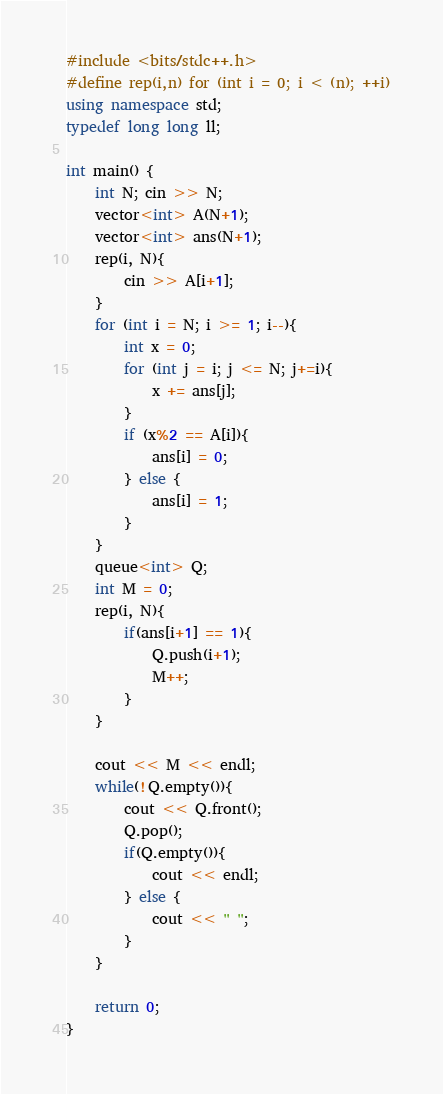Convert code to text. <code><loc_0><loc_0><loc_500><loc_500><_C++_>#include <bits/stdc++.h>
#define rep(i,n) for (int i = 0; i < (n); ++i)
using namespace std;
typedef long long ll;

int main() {
    int N; cin >> N;
    vector<int> A(N+1);
    vector<int> ans(N+1);
    rep(i, N){
        cin >> A[i+1];
    }
    for (int i = N; i >= 1; i--){
        int x = 0;
        for (int j = i; j <= N; j+=i){
            x += ans[j];
        }
        if (x%2 == A[i]){
            ans[i] = 0;
        } else {
            ans[i] = 1;
        }
    }
    queue<int> Q;
    int M = 0;
    rep(i, N){
        if(ans[i+1] == 1){
            Q.push(i+1);
            M++;
        }
    }

    cout << M << endl;
    while(!Q.empty()){
        cout << Q.front();
        Q.pop();
        if(Q.empty()){
            cout << endl;
        } else {
            cout << " ";
        }
    }

    return 0;
}</code> 